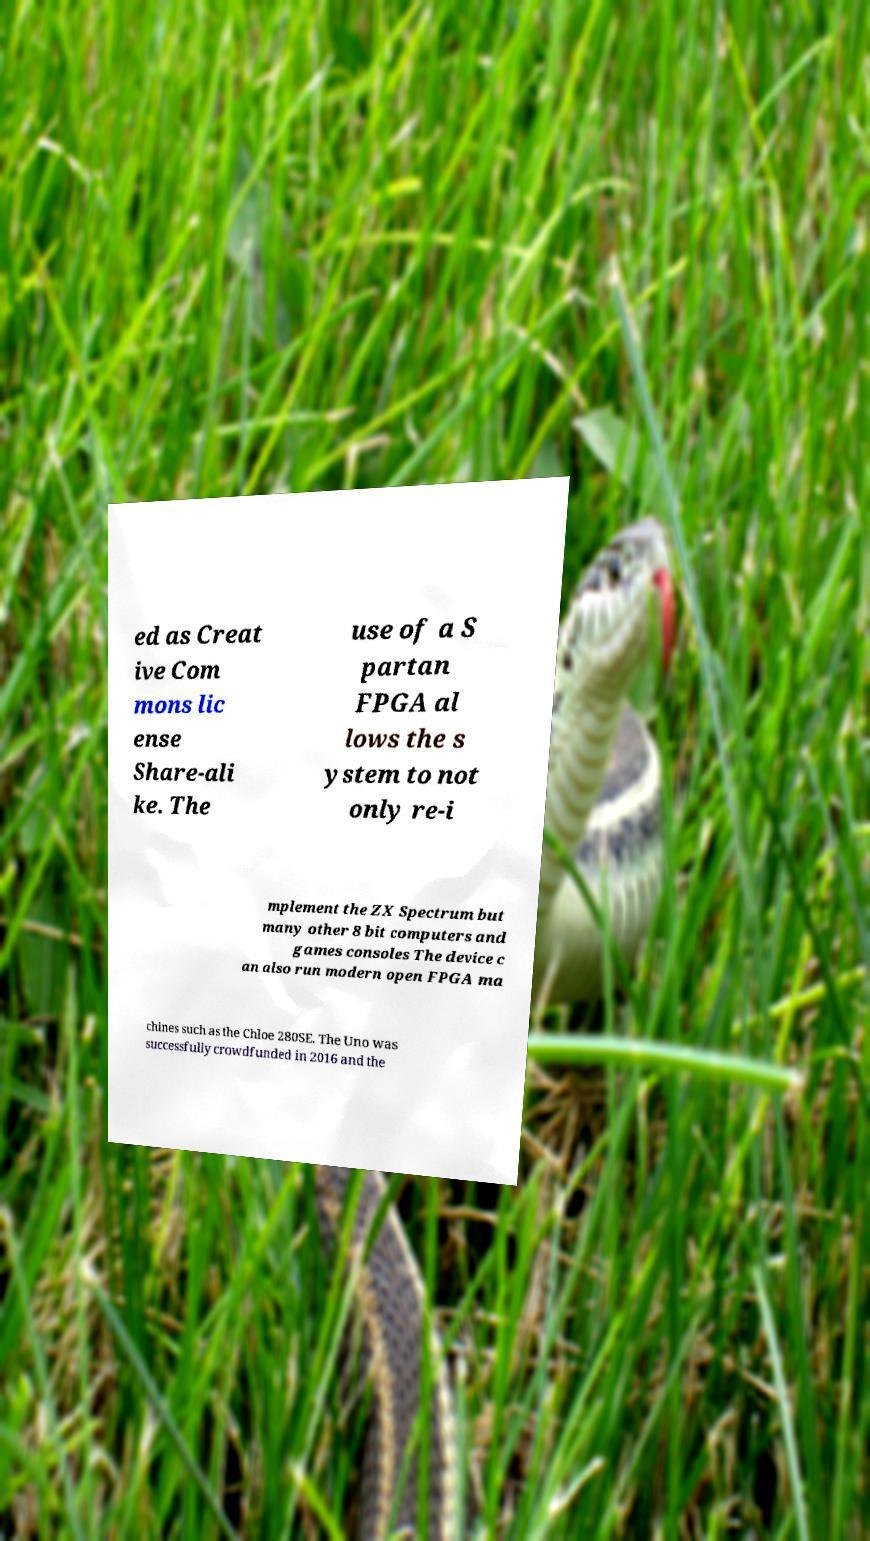Please read and relay the text visible in this image. What does it say? ed as Creat ive Com mons lic ense Share-ali ke. The use of a S partan FPGA al lows the s ystem to not only re-i mplement the ZX Spectrum but many other 8 bit computers and games consoles The device c an also run modern open FPGA ma chines such as the Chloe 280SE. The Uno was successfully crowdfunded in 2016 and the 